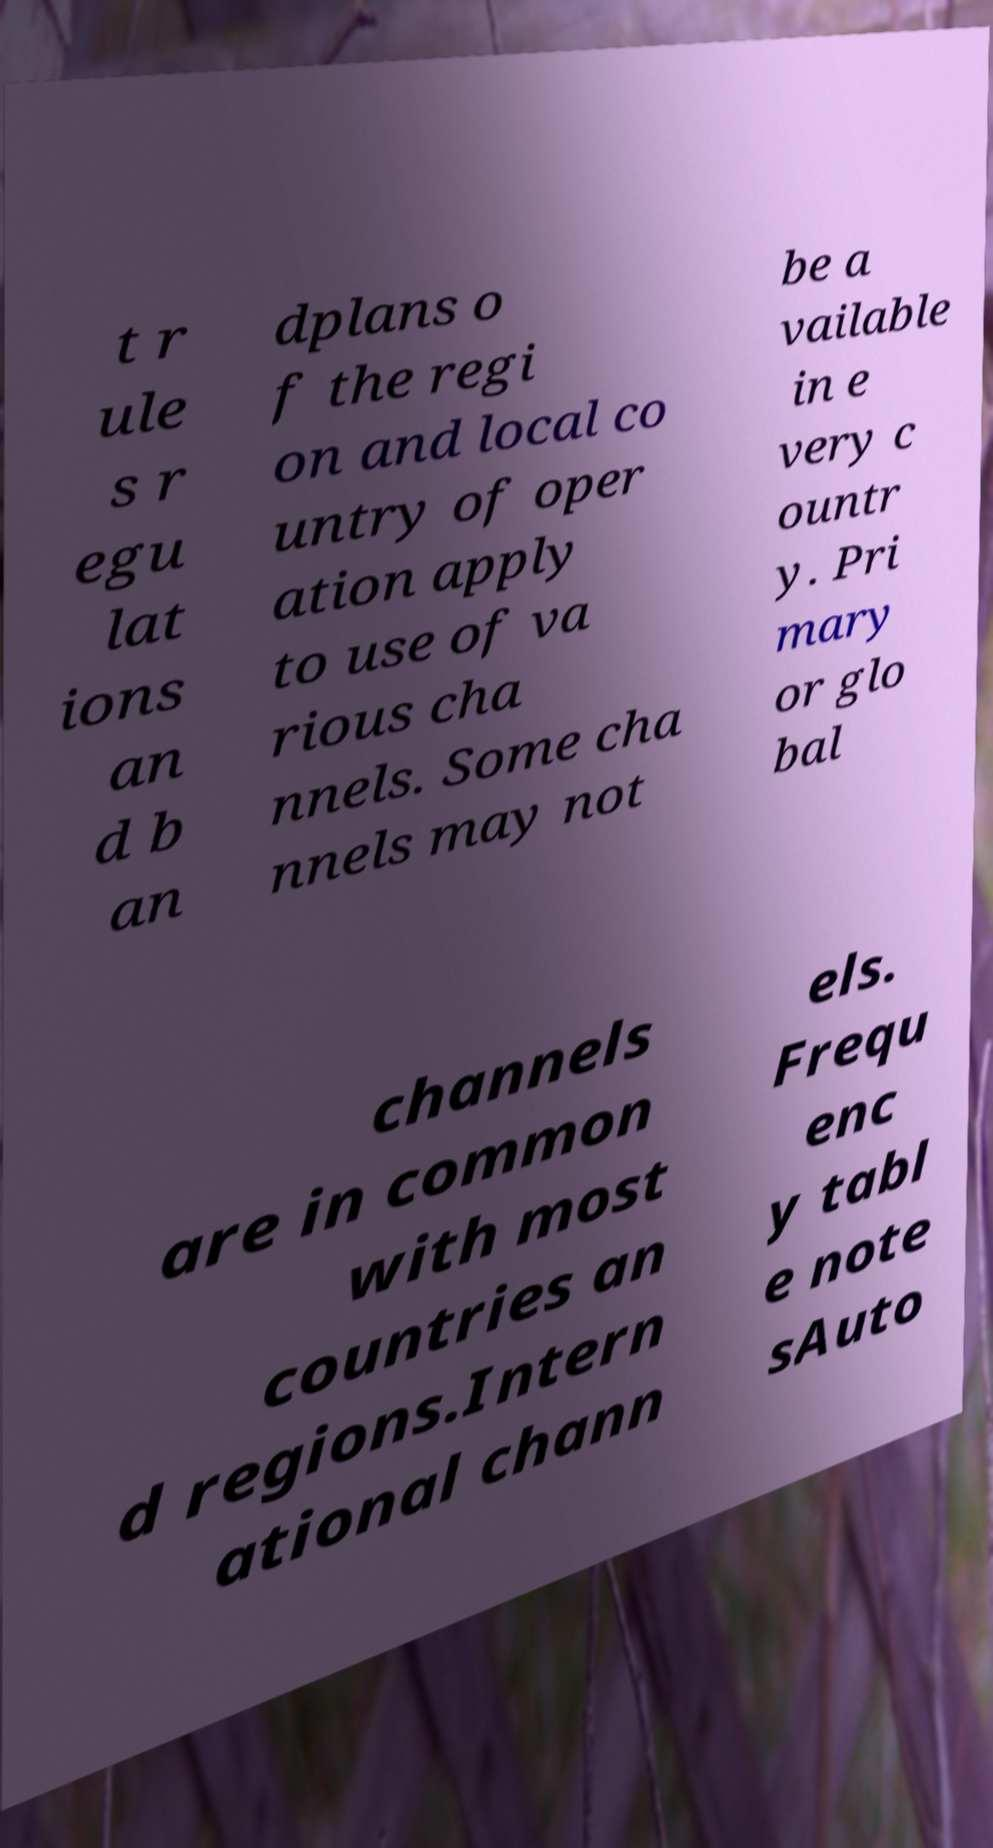Please read and relay the text visible in this image. What does it say? t r ule s r egu lat ions an d b an dplans o f the regi on and local co untry of oper ation apply to use of va rious cha nnels. Some cha nnels may not be a vailable in e very c ountr y. Pri mary or glo bal channels are in common with most countries an d regions.Intern ational chann els. Frequ enc y tabl e note sAuto 